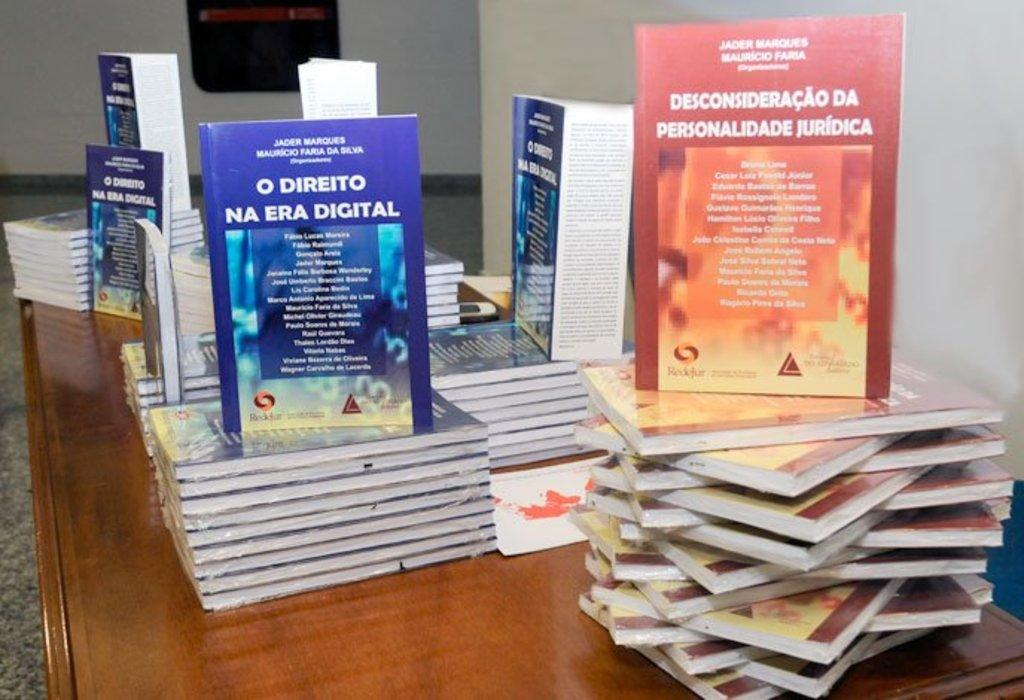<image>
Share a concise interpretation of the image provided. A table containing a few piles of books including the title O Direito Na Era Digital. 